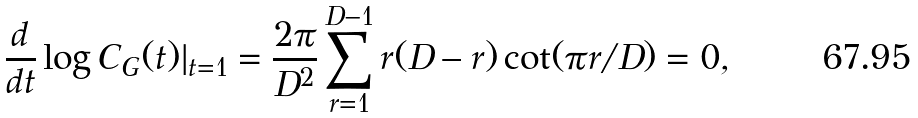Convert formula to latex. <formula><loc_0><loc_0><loc_500><loc_500>\frac { d } { d t } \log C _ { G } ( t ) | _ { t = 1 } = \frac { 2 \pi } { D ^ { 2 } } \sum _ { r = 1 } ^ { D - 1 } r ( D - r ) \cot ( \pi r / D ) = 0 ,</formula> 